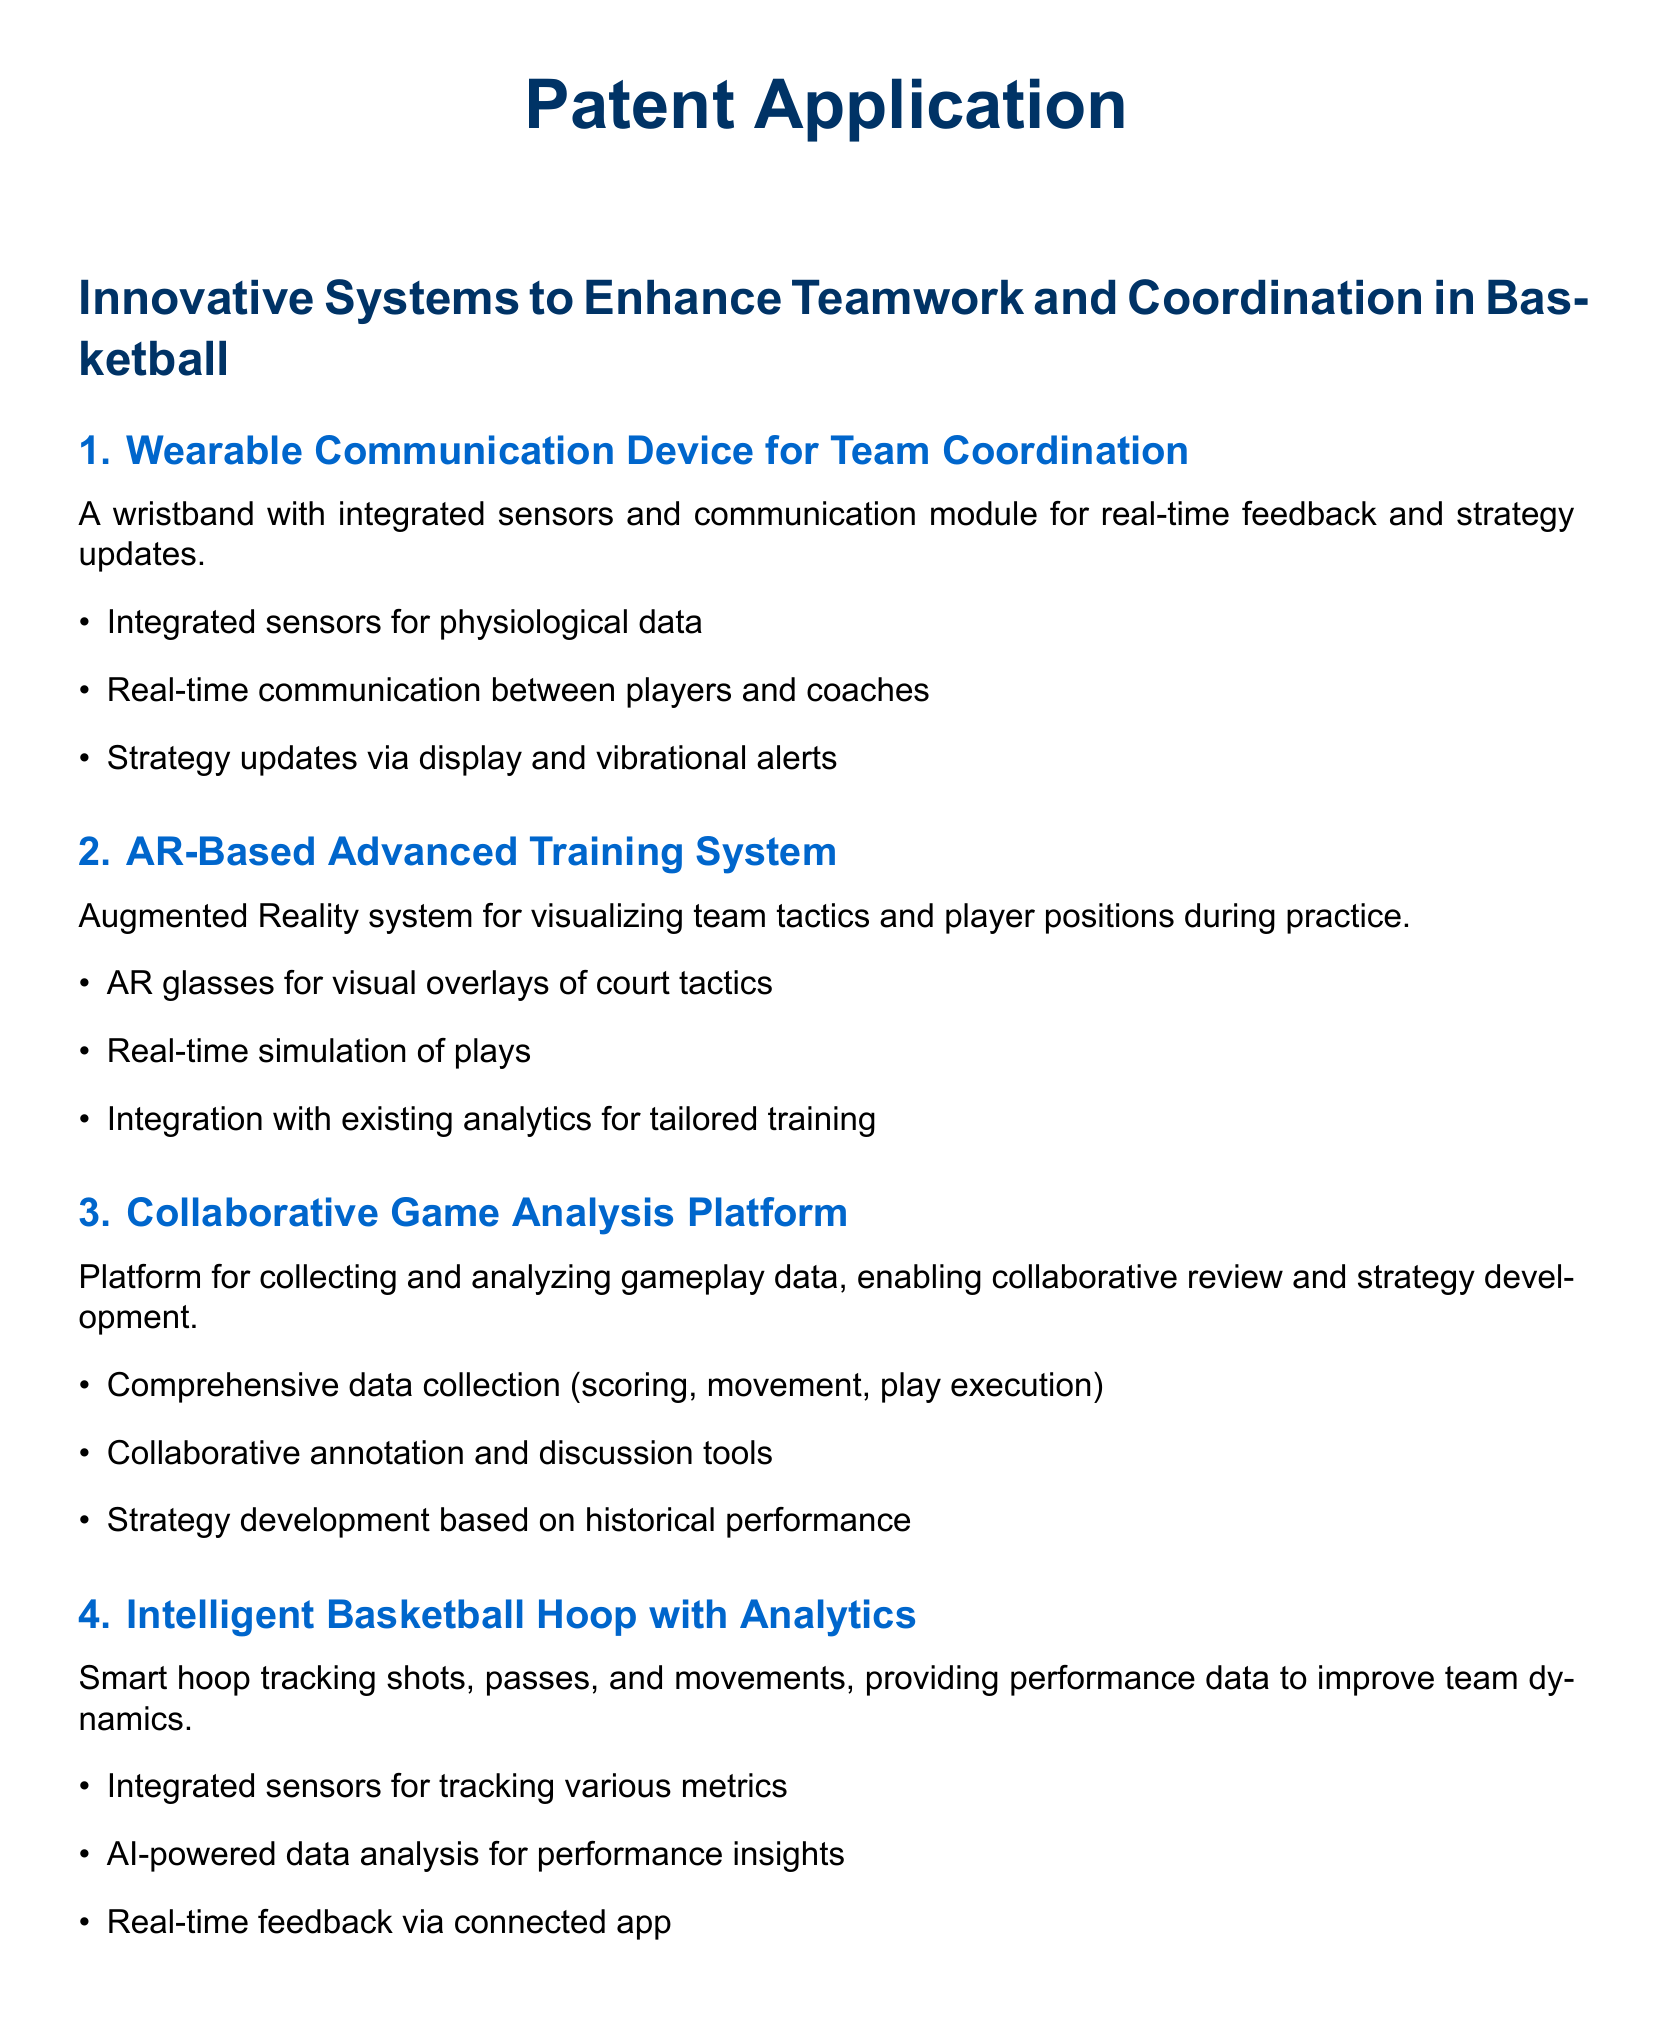What is the main purpose of the patent application? The main purpose is to enhance teamwork and coordination in basketball through innovative technological solutions.
Answer: Enhance teamwork and coordination What type of device does the first subsection describe? The first subsection describes a wearable communication device.
Answer: Wearable communication device What technology is used in the second innovation? The technology used is augmented reality (AR).
Answer: Augmented reality What key feature does the Collaborative Game Analysis Platform provide? The key feature is collaborative review and strategy development based on gameplay data.
Answer: Collaborative review and strategy development How does the intelligent basketball hoop improve team dynamics? It provides performance data through tracking shots, passes, and movements.
Answer: Performance data What is monitored by the Team-Based Fitness Tracking System? It monitors the collective fitness and health of sports teams.
Answer: Collective fitness and health 